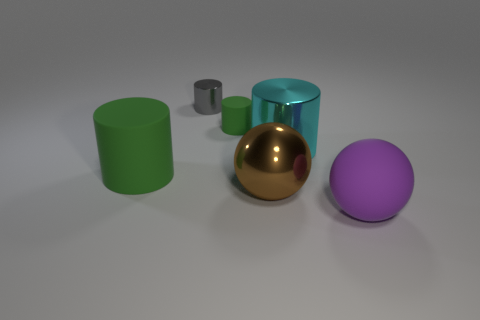Subtract all small green rubber cylinders. How many cylinders are left? 3 Add 2 cyan metal cylinders. How many objects exist? 8 Subtract 2 spheres. How many spheres are left? 0 Subtract all purple cylinders. Subtract all cyan balls. How many cylinders are left? 4 Subtract all yellow spheres. How many red cylinders are left? 0 Subtract all large purple rubber objects. Subtract all big matte objects. How many objects are left? 3 Add 5 big brown balls. How many big brown balls are left? 6 Add 4 small blue blocks. How many small blue blocks exist? 4 Subtract all purple balls. How many balls are left? 1 Subtract 0 yellow cylinders. How many objects are left? 6 